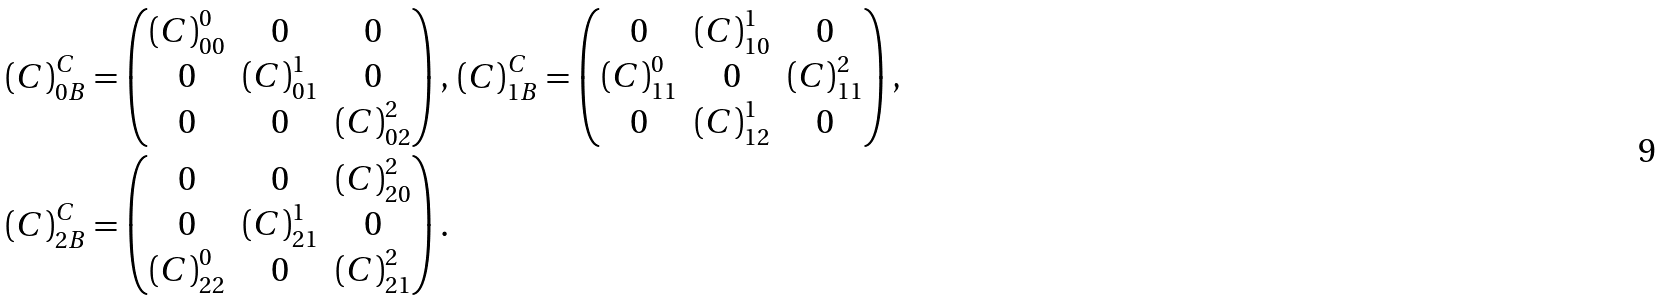<formula> <loc_0><loc_0><loc_500><loc_500>& \left ( C \right ) _ { 0 B } ^ { C } = \begin{pmatrix} { ( C ) } _ { 0 0 } ^ { 0 } & 0 & 0 \\ 0 & { ( C ) } _ { 0 1 } ^ { 1 } & 0 \\ 0 & 0 & { ( C ) } _ { 0 2 } ^ { 2 } \end{pmatrix} , \, \left ( C \right ) _ { 1 B } ^ { C } = \begin{pmatrix} 0 & { ( C ) } _ { 1 0 } ^ { 1 } & 0 \\ { ( C ) } _ { 1 1 } ^ { 0 } & 0 & { ( C ) } _ { 1 1 } ^ { 2 } \\ 0 & { ( C ) } _ { 1 2 } ^ { 1 } & 0 \end{pmatrix} , \\ & \left ( C \right ) _ { 2 B } ^ { C } = \begin{pmatrix} 0 & 0 & { ( C ) } _ { 2 0 } ^ { 2 } \\ 0 & { ( C ) } _ { 2 1 } ^ { 1 } & 0 \\ { ( C ) } _ { 2 2 } ^ { 0 } & 0 & { ( C ) } _ { 2 1 } ^ { 2 } \end{pmatrix} .</formula> 